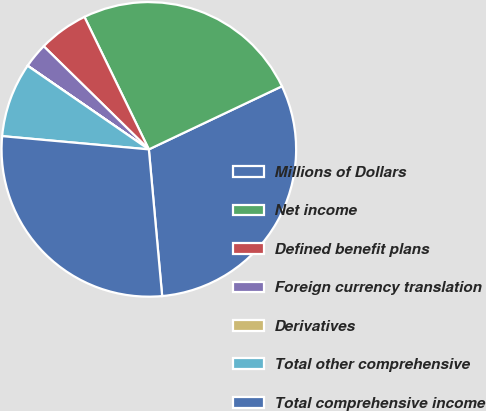Convert chart. <chart><loc_0><loc_0><loc_500><loc_500><pie_chart><fcel>Millions of Dollars<fcel>Net income<fcel>Defined benefit plans<fcel>Foreign currency translation<fcel>Derivatives<fcel>Total other comprehensive<fcel>Total comprehensive income<nl><fcel>30.6%<fcel>25.15%<fcel>5.45%<fcel>2.73%<fcel>0.01%<fcel>8.17%<fcel>27.87%<nl></chart> 